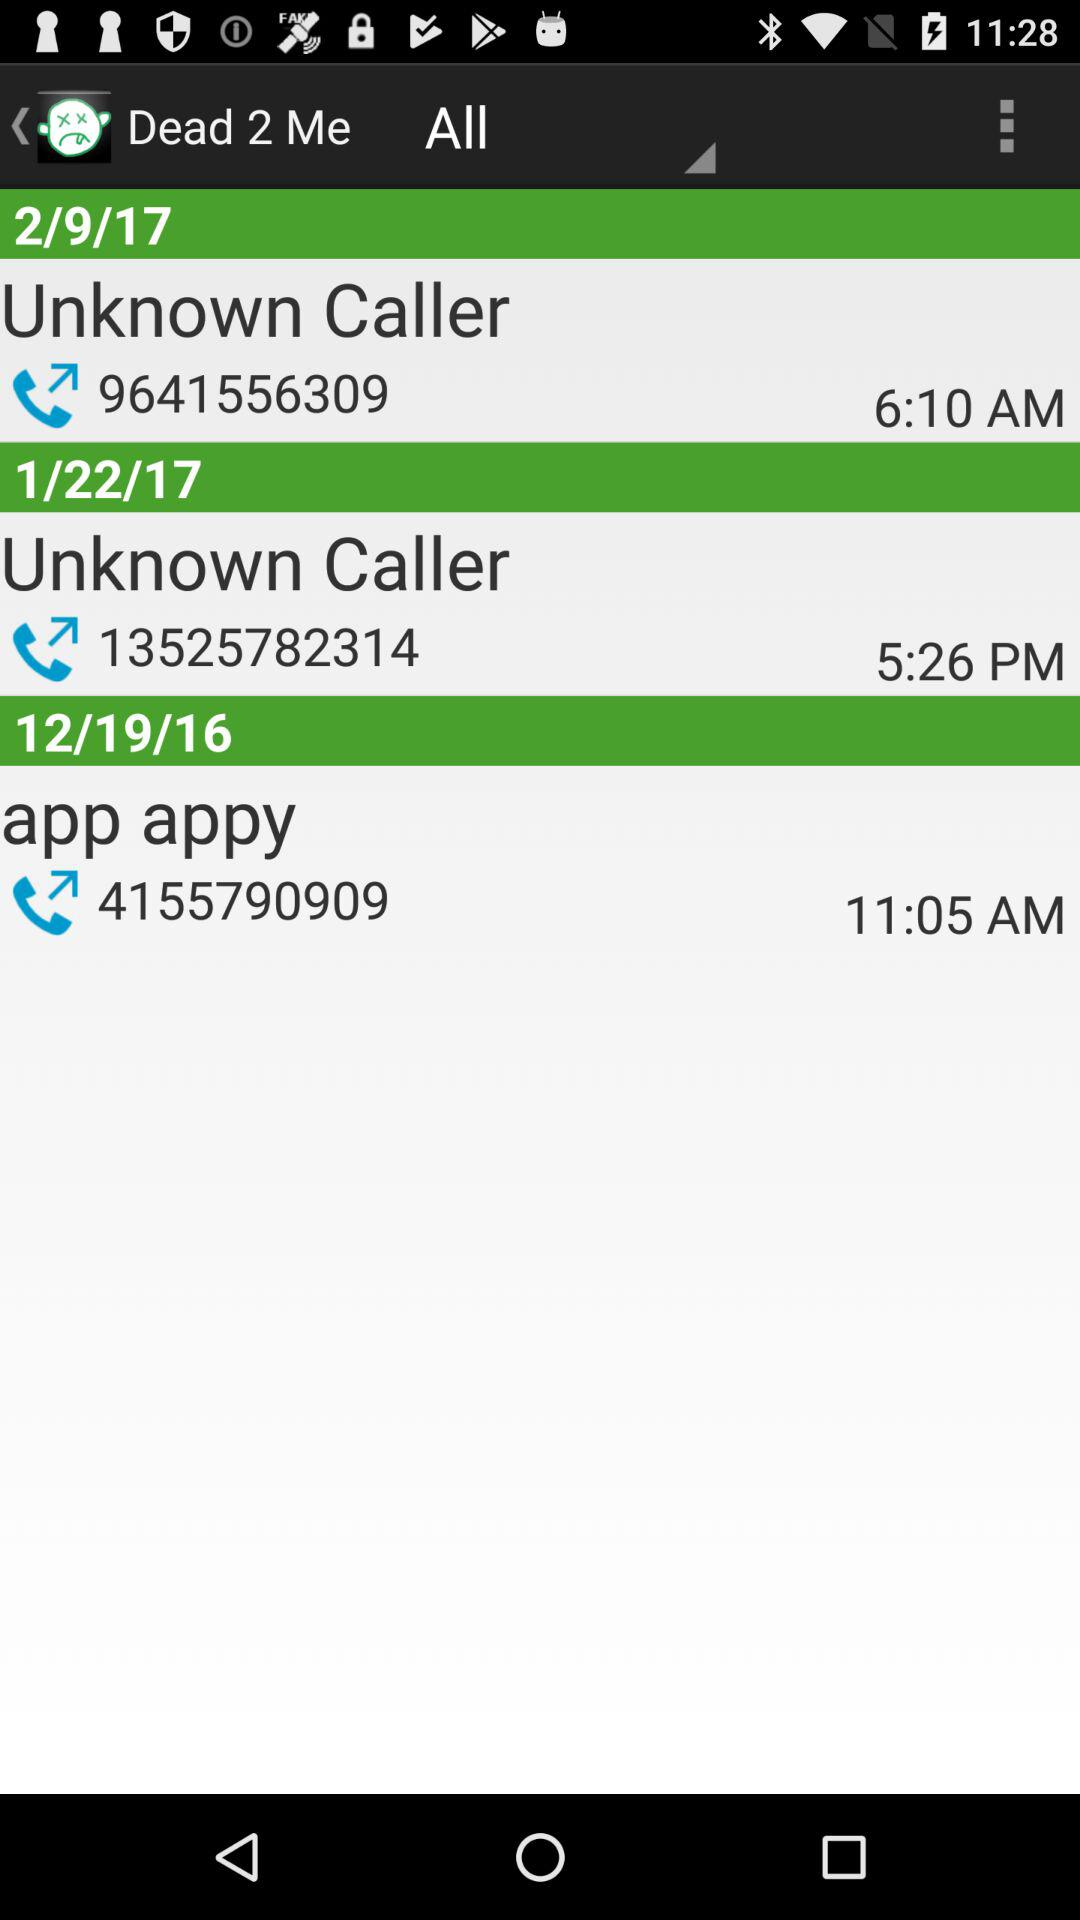On what date did I call the number starting with 9641? You call the number on February 9, 2017. 